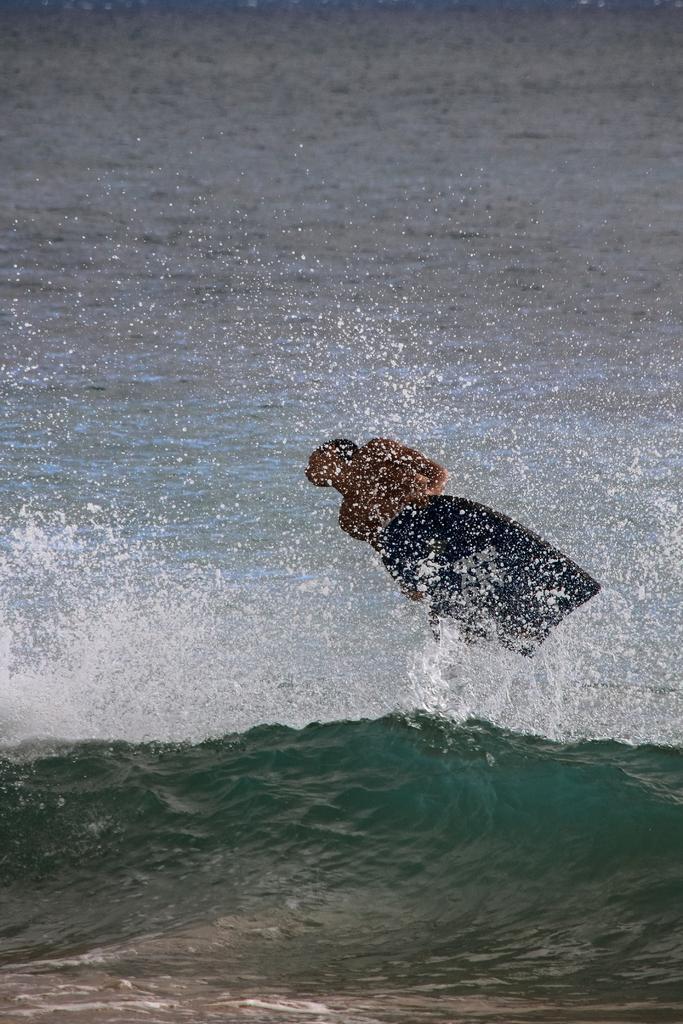In one or two sentences, can you explain what this image depicts? In this image we can see a man is surfing on the water. 